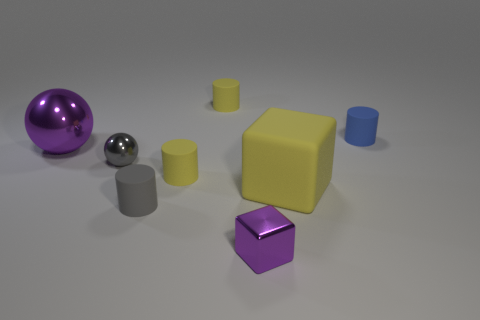What material is the other object that is the same color as the big shiny object?
Your answer should be compact. Metal. Are there any other things that are the same shape as the small gray metallic object?
Provide a succinct answer. Yes. What is the material of the small thing that is behind the tiny gray rubber thing and in front of the gray ball?
Give a very brief answer. Rubber. Are the small ball and the large object to the left of the small gray cylinder made of the same material?
Your answer should be compact. Yes. Is there any other thing that has the same size as the metal block?
Offer a very short reply. Yes. What number of things are small green balls or small things to the right of the tiny purple metallic thing?
Provide a succinct answer. 1. There is a yellow rubber cylinder that is behind the big shiny thing; is it the same size as the yellow rubber cylinder in front of the big ball?
Your answer should be very brief. Yes. How many other objects are there of the same color as the large metallic ball?
Ensure brevity in your answer.  1. There is a gray matte cylinder; is its size the same as the yellow rubber cylinder that is behind the purple ball?
Give a very brief answer. Yes. There is a matte object that is in front of the large object in front of the small metal ball; how big is it?
Your answer should be compact. Small. 